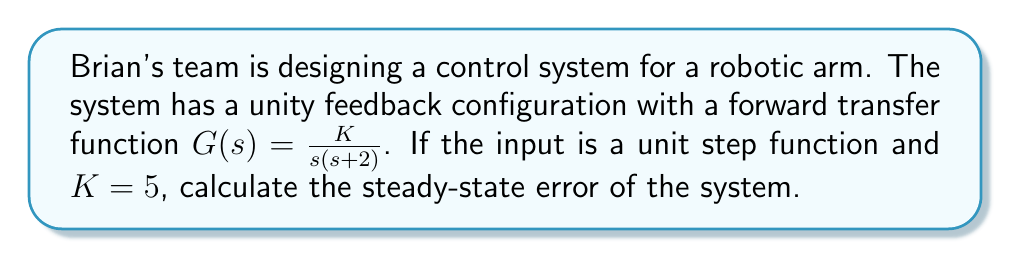What is the answer to this math problem? To calculate the steady-state error for a step input, we'll follow these steps:

1) First, determine the system type. The forward transfer function $G(s) = \frac{K}{s(s+2)}$ has one pole at $s=0$, so this is a Type 1 system.

2) For a Type 1 system with a step input, the steady-state error is given by:

   $$e_{ss} = \frac{1}{1 + K_p}$$

   where $K_p$ is the position error constant.

3) To find $K_p$, we use the formula:

   $$K_p = \lim_{s \to 0} sG(s)$$

4) Substituting our transfer function:

   $$K_p = \lim_{s \to 0} s \cdot \frac{K}{s(s+2)}$$

5) Simplify:

   $$K_p = \lim_{s \to 0} \frac{K}{s+2} = \frac{K}{2}$$

6) Given that $K = 5$:

   $$K_p = \frac{5}{2} = 2.5$$

7) Now we can calculate the steady-state error:

   $$e_{ss} = \frac{1}{1 + K_p} = \frac{1}{1 + 2.5} = \frac{1}{3.5}$$

8) Simplify the fraction:

   $$e_{ss} = \frac{2}{7}$$
Answer: The steady-state error of the system is $\frac{2}{7}$ or approximately $0.2857$. 